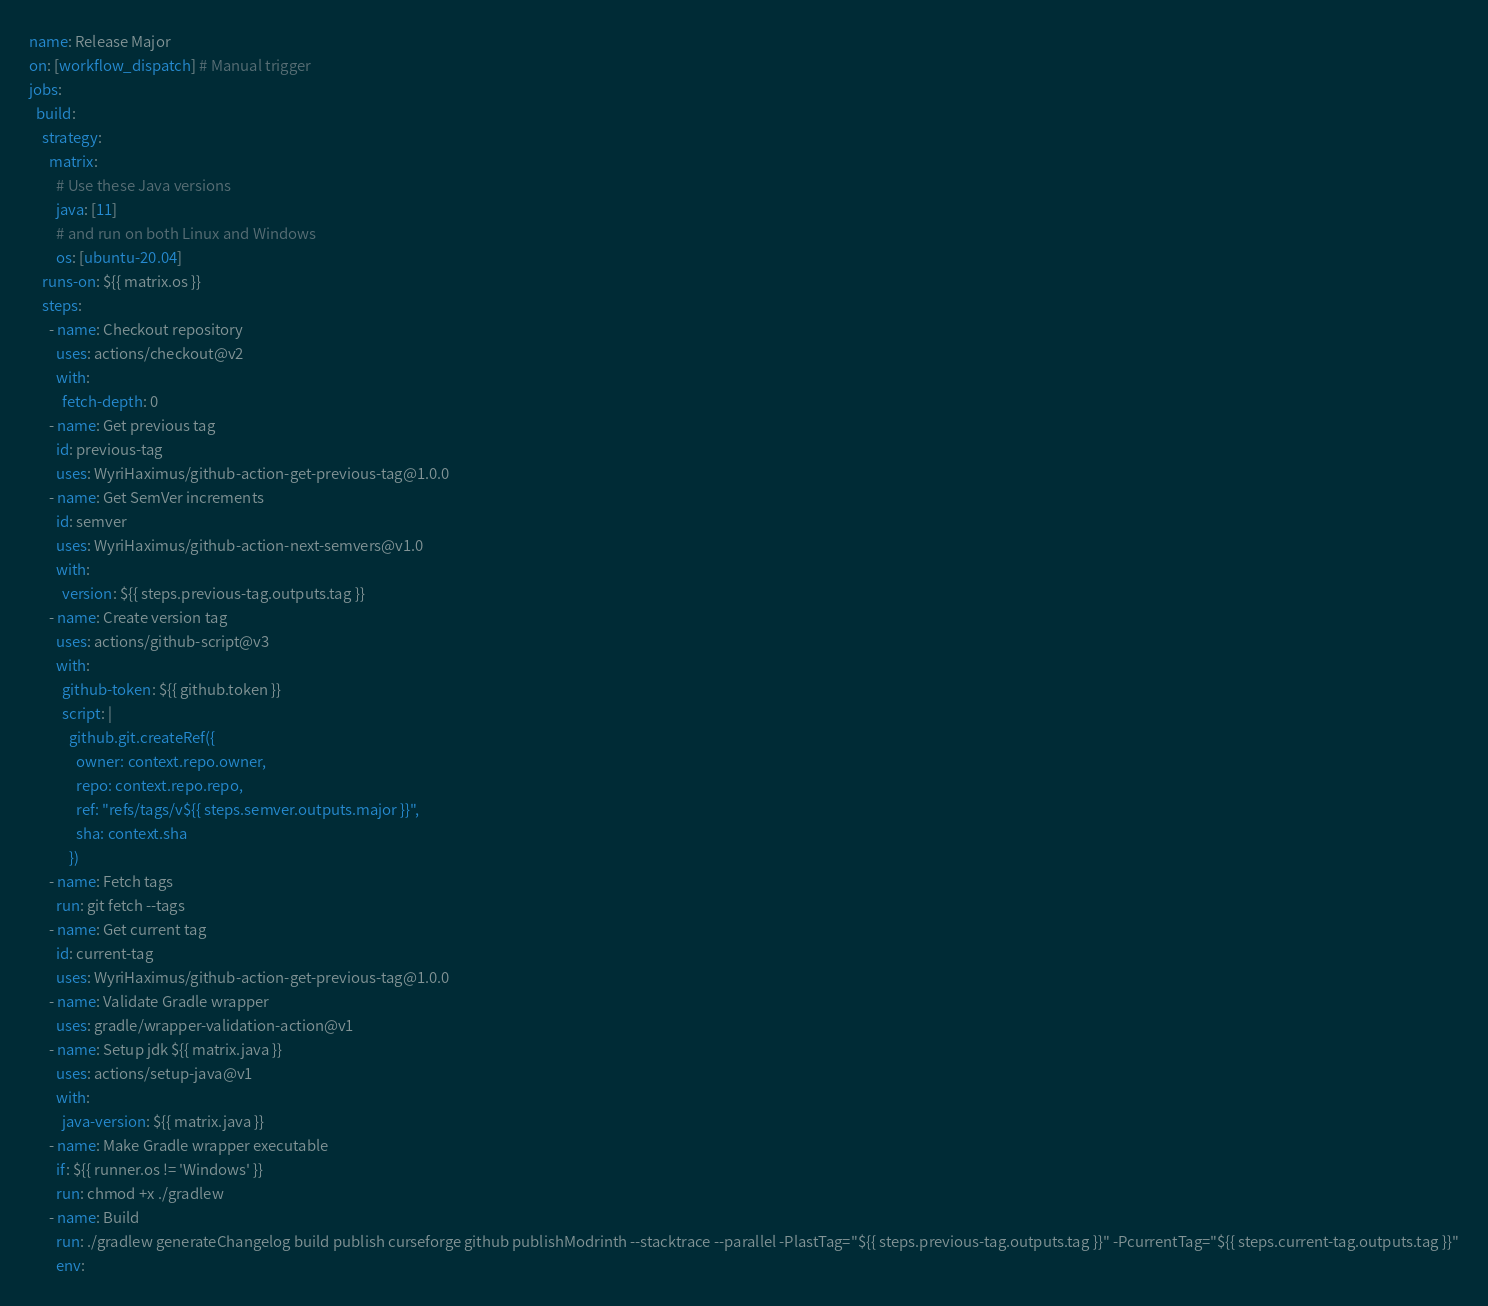Convert code to text. <code><loc_0><loc_0><loc_500><loc_500><_YAML_>name: Release Major
on: [workflow_dispatch] # Manual trigger
jobs:
  build:
    strategy:
      matrix:
        # Use these Java versions
        java: [11]
        # and run on both Linux and Windows
        os: [ubuntu-20.04]
    runs-on: ${{ matrix.os }}
    steps:
      - name: Checkout repository
        uses: actions/checkout@v2
        with:
          fetch-depth: 0
      - name: Get previous tag
        id: previous-tag
        uses: WyriHaximus/github-action-get-previous-tag@1.0.0
      - name: Get SemVer increments
        id: semver
        uses: WyriHaximus/github-action-next-semvers@v1.0
        with:
          version: ${{ steps.previous-tag.outputs.tag }}
      - name: Create version tag
        uses: actions/github-script@v3
        with:
          github-token: ${{ github.token }}
          script: |
            github.git.createRef({
              owner: context.repo.owner,
              repo: context.repo.repo,
              ref: "refs/tags/v${{ steps.semver.outputs.major }}",
              sha: context.sha
            })
      - name: Fetch tags
        run: git fetch --tags
      - name: Get current tag
        id: current-tag
        uses: WyriHaximus/github-action-get-previous-tag@1.0.0
      - name: Validate Gradle wrapper
        uses: gradle/wrapper-validation-action@v1
      - name: Setup jdk ${{ matrix.java }}
        uses: actions/setup-java@v1
        with:
          java-version: ${{ matrix.java }}
      - name: Make Gradle wrapper executable
        if: ${{ runner.os != 'Windows' }}
        run: chmod +x ./gradlew
      - name: Build
        run: ./gradlew generateChangelog build publish curseforge github publishModrinth --stacktrace --parallel -PlastTag="${{ steps.previous-tag.outputs.tag }}" -PcurrentTag="${{ steps.current-tag.outputs.tag }}"
        env:</code> 